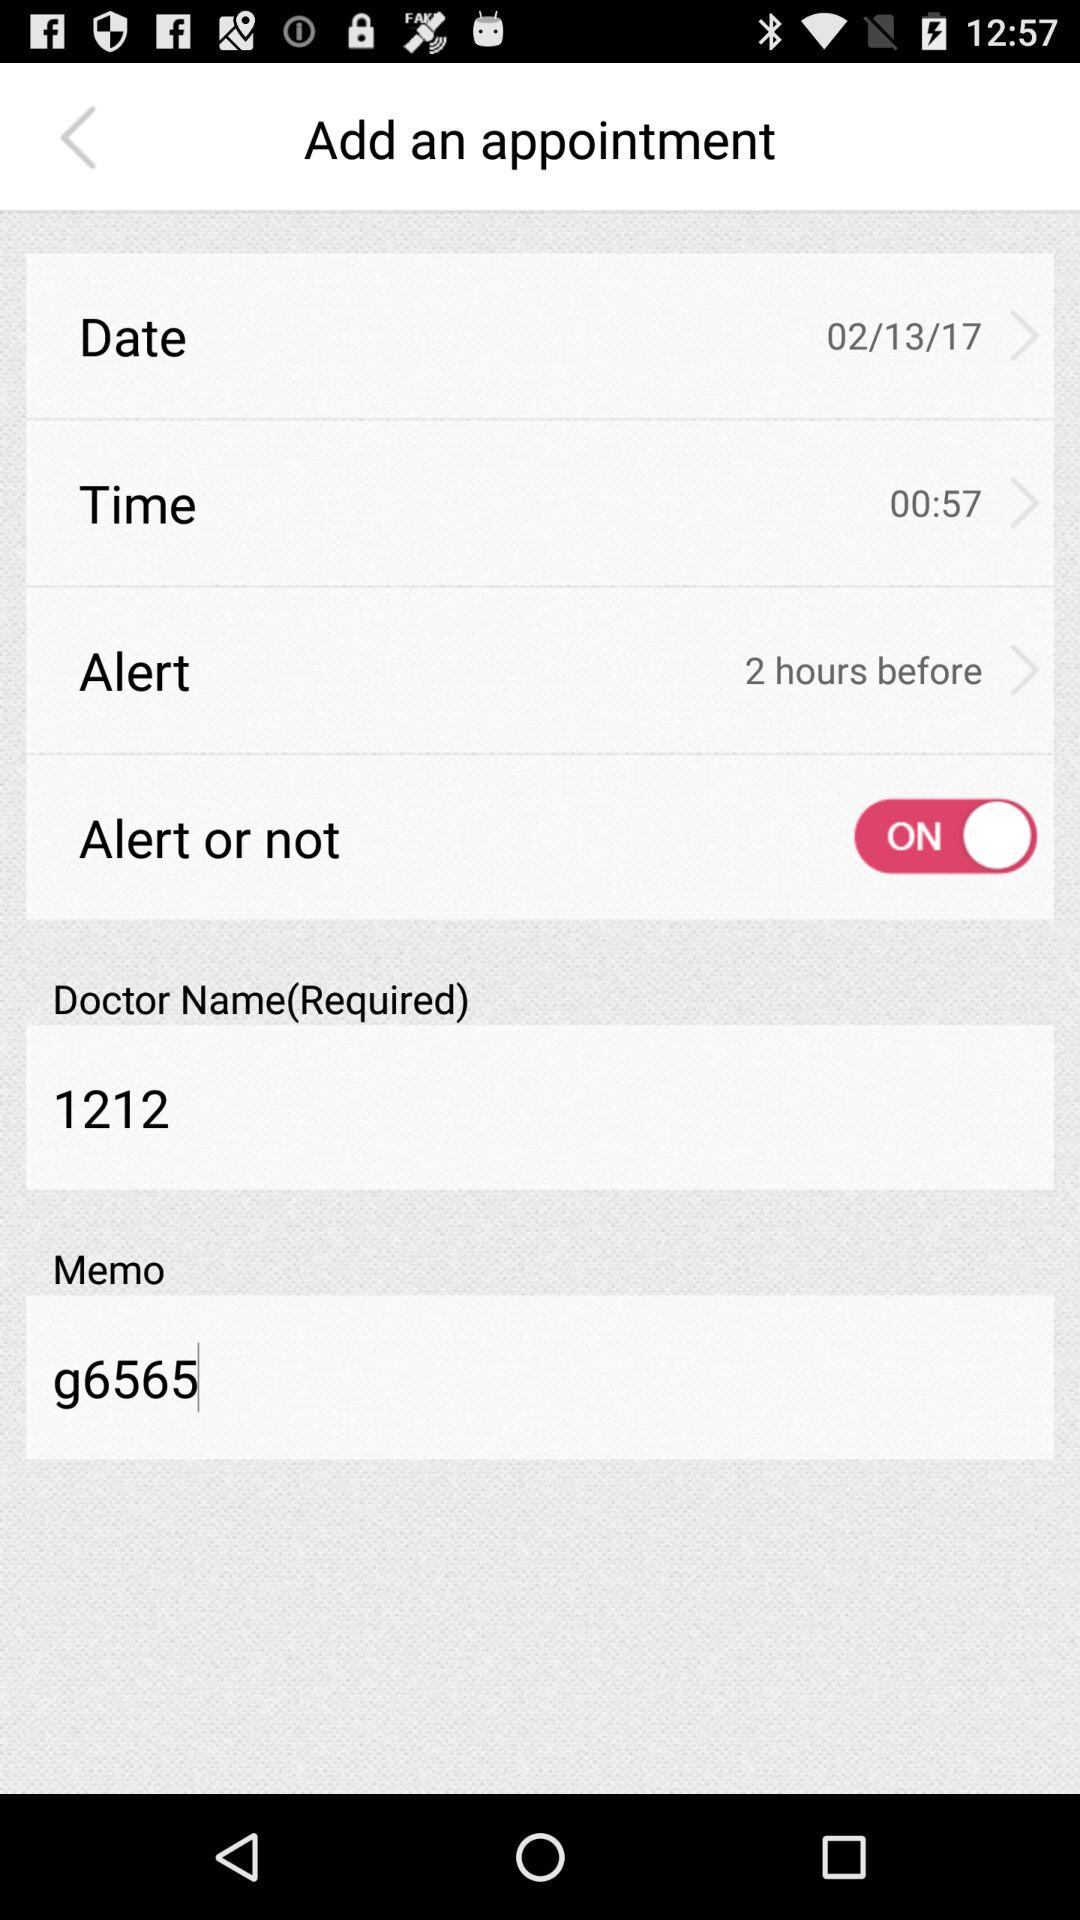How many appointments does the user have?
When the provided information is insufficient, respond with <no answer>. <no answer> 